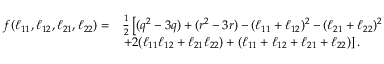Convert formula to latex. <formula><loc_0><loc_0><loc_500><loc_500>\begin{array} { r l } { f ( \ell _ { 1 1 } , \ell _ { 1 2 } , \ell _ { 2 1 } , \ell _ { 2 2 } ) = } & { \frac { 1 } { 2 } \left [ ( q ^ { 2 } - 3 q ) + ( r ^ { 2 } - 3 r ) - ( \ell _ { 1 1 } + \ell _ { 1 2 } ) ^ { 2 } - ( \ell _ { 2 1 } + \ell _ { 2 2 } ) ^ { 2 } } \\ & { + 2 ( \ell _ { 1 1 } \ell _ { 1 2 } + \ell _ { 2 1 } \ell _ { 2 2 } ) + ( \ell _ { 1 1 } + \ell _ { 1 2 } + \ell _ { 2 1 } + \ell _ { 2 2 } ) \right ] . } \end{array}</formula> 